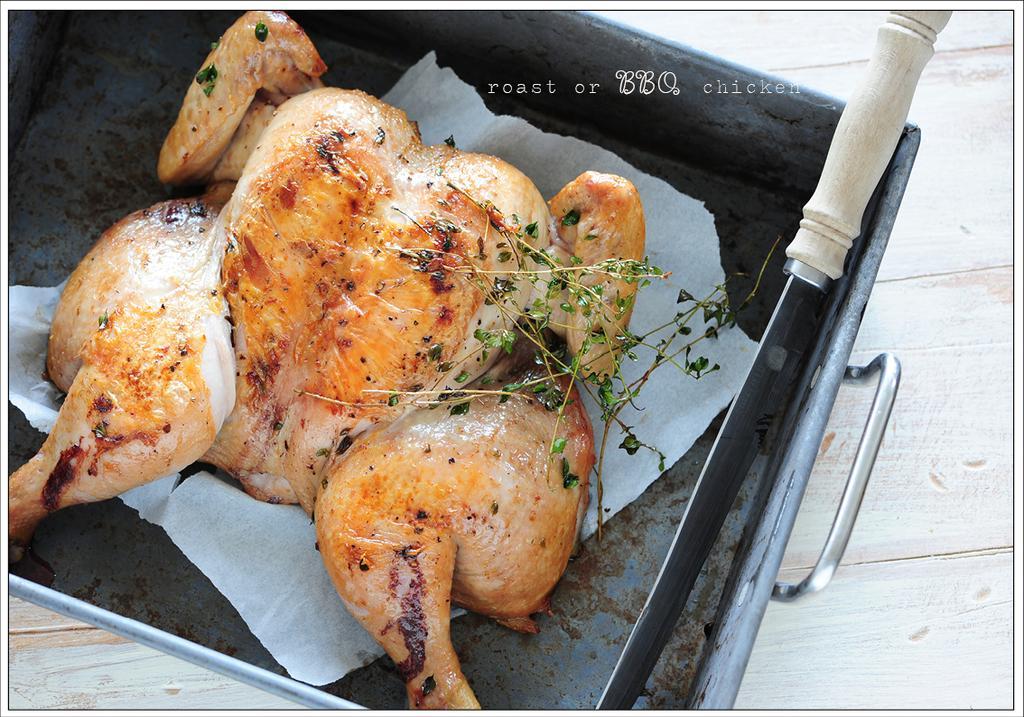Describe this image in one or two sentences. In this picture, we see a tray or a vessel containing the chicken meat, tissue paper, mint leaves and a knife are placed on the wooden table. 